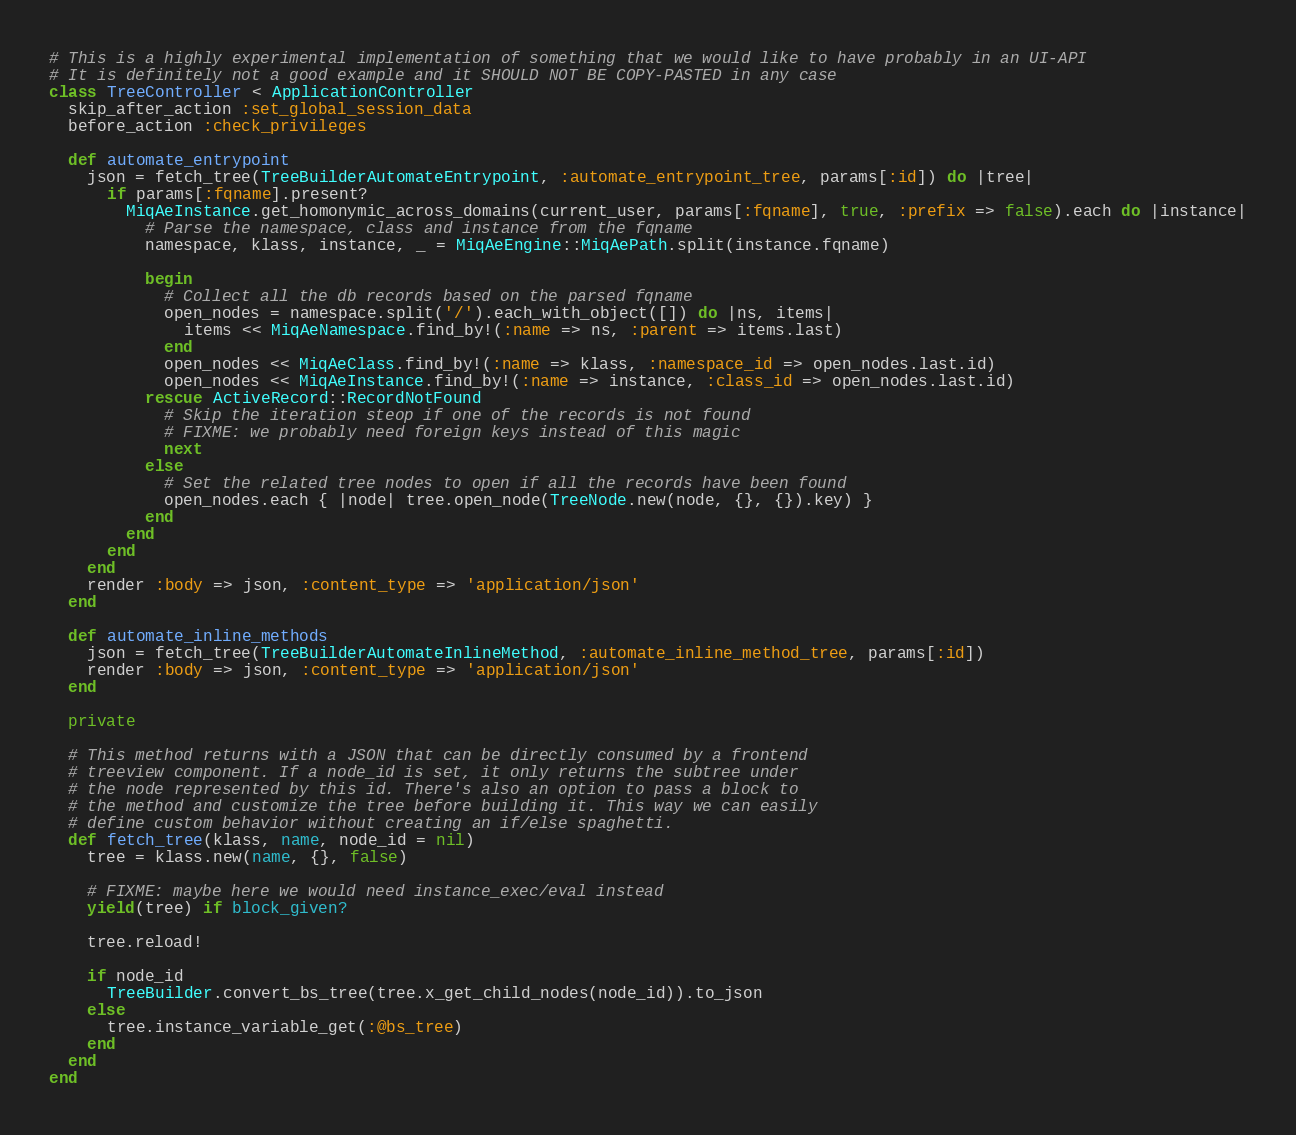Convert code to text. <code><loc_0><loc_0><loc_500><loc_500><_Ruby_># This is a highly experimental implementation of something that we would like to have probably in an UI-API
# It is definitely not a good example and it SHOULD NOT BE COPY-PASTED in any case
class TreeController < ApplicationController
  skip_after_action :set_global_session_data
  before_action :check_privileges

  def automate_entrypoint
    json = fetch_tree(TreeBuilderAutomateEntrypoint, :automate_entrypoint_tree, params[:id]) do |tree|
      if params[:fqname].present?
        MiqAeInstance.get_homonymic_across_domains(current_user, params[:fqname], true, :prefix => false).each do |instance|
          # Parse the namespace, class and instance from the fqname
          namespace, klass, instance, _ = MiqAeEngine::MiqAePath.split(instance.fqname)

          begin
            # Collect all the db records based on the parsed fqname
            open_nodes = namespace.split('/').each_with_object([]) do |ns, items|
              items << MiqAeNamespace.find_by!(:name => ns, :parent => items.last)
            end
            open_nodes << MiqAeClass.find_by!(:name => klass, :namespace_id => open_nodes.last.id)
            open_nodes << MiqAeInstance.find_by!(:name => instance, :class_id => open_nodes.last.id)
          rescue ActiveRecord::RecordNotFound
            # Skip the iteration steop if one of the records is not found
            # FIXME: we probably need foreign keys instead of this magic
            next
          else
            # Set the related tree nodes to open if all the records have been found
            open_nodes.each { |node| tree.open_node(TreeNode.new(node, {}, {}).key) }
          end
        end
      end
    end
    render :body => json, :content_type => 'application/json'
  end

  def automate_inline_methods
    json = fetch_tree(TreeBuilderAutomateInlineMethod, :automate_inline_method_tree, params[:id])
    render :body => json, :content_type => 'application/json'
  end

  private

  # This method returns with a JSON that can be directly consumed by a frontend
  # treeview component. If a node_id is set, it only returns the subtree under
  # the node represented by this id. There's also an option to pass a block to
  # the method and customize the tree before building it. This way we can easily
  # define custom behavior without creating an if/else spaghetti.
  def fetch_tree(klass, name, node_id = nil)
    tree = klass.new(name, {}, false)

    # FIXME: maybe here we would need instance_exec/eval instead
    yield(tree) if block_given?

    tree.reload!

    if node_id
      TreeBuilder.convert_bs_tree(tree.x_get_child_nodes(node_id)).to_json
    else
      tree.instance_variable_get(:@bs_tree)
    end
  end
end
</code> 